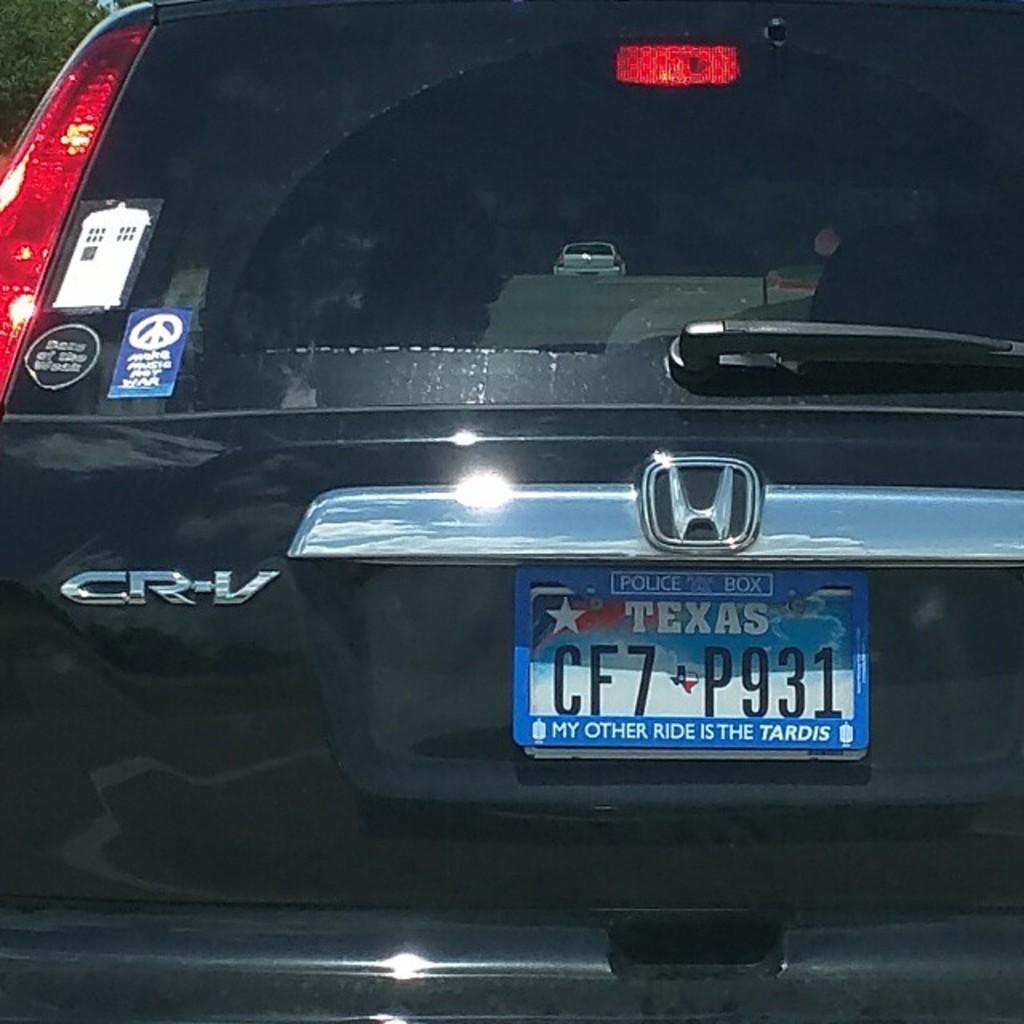Are they from texas?
Your answer should be compact. Yes. What state are they from?
Provide a succinct answer. Texas. 